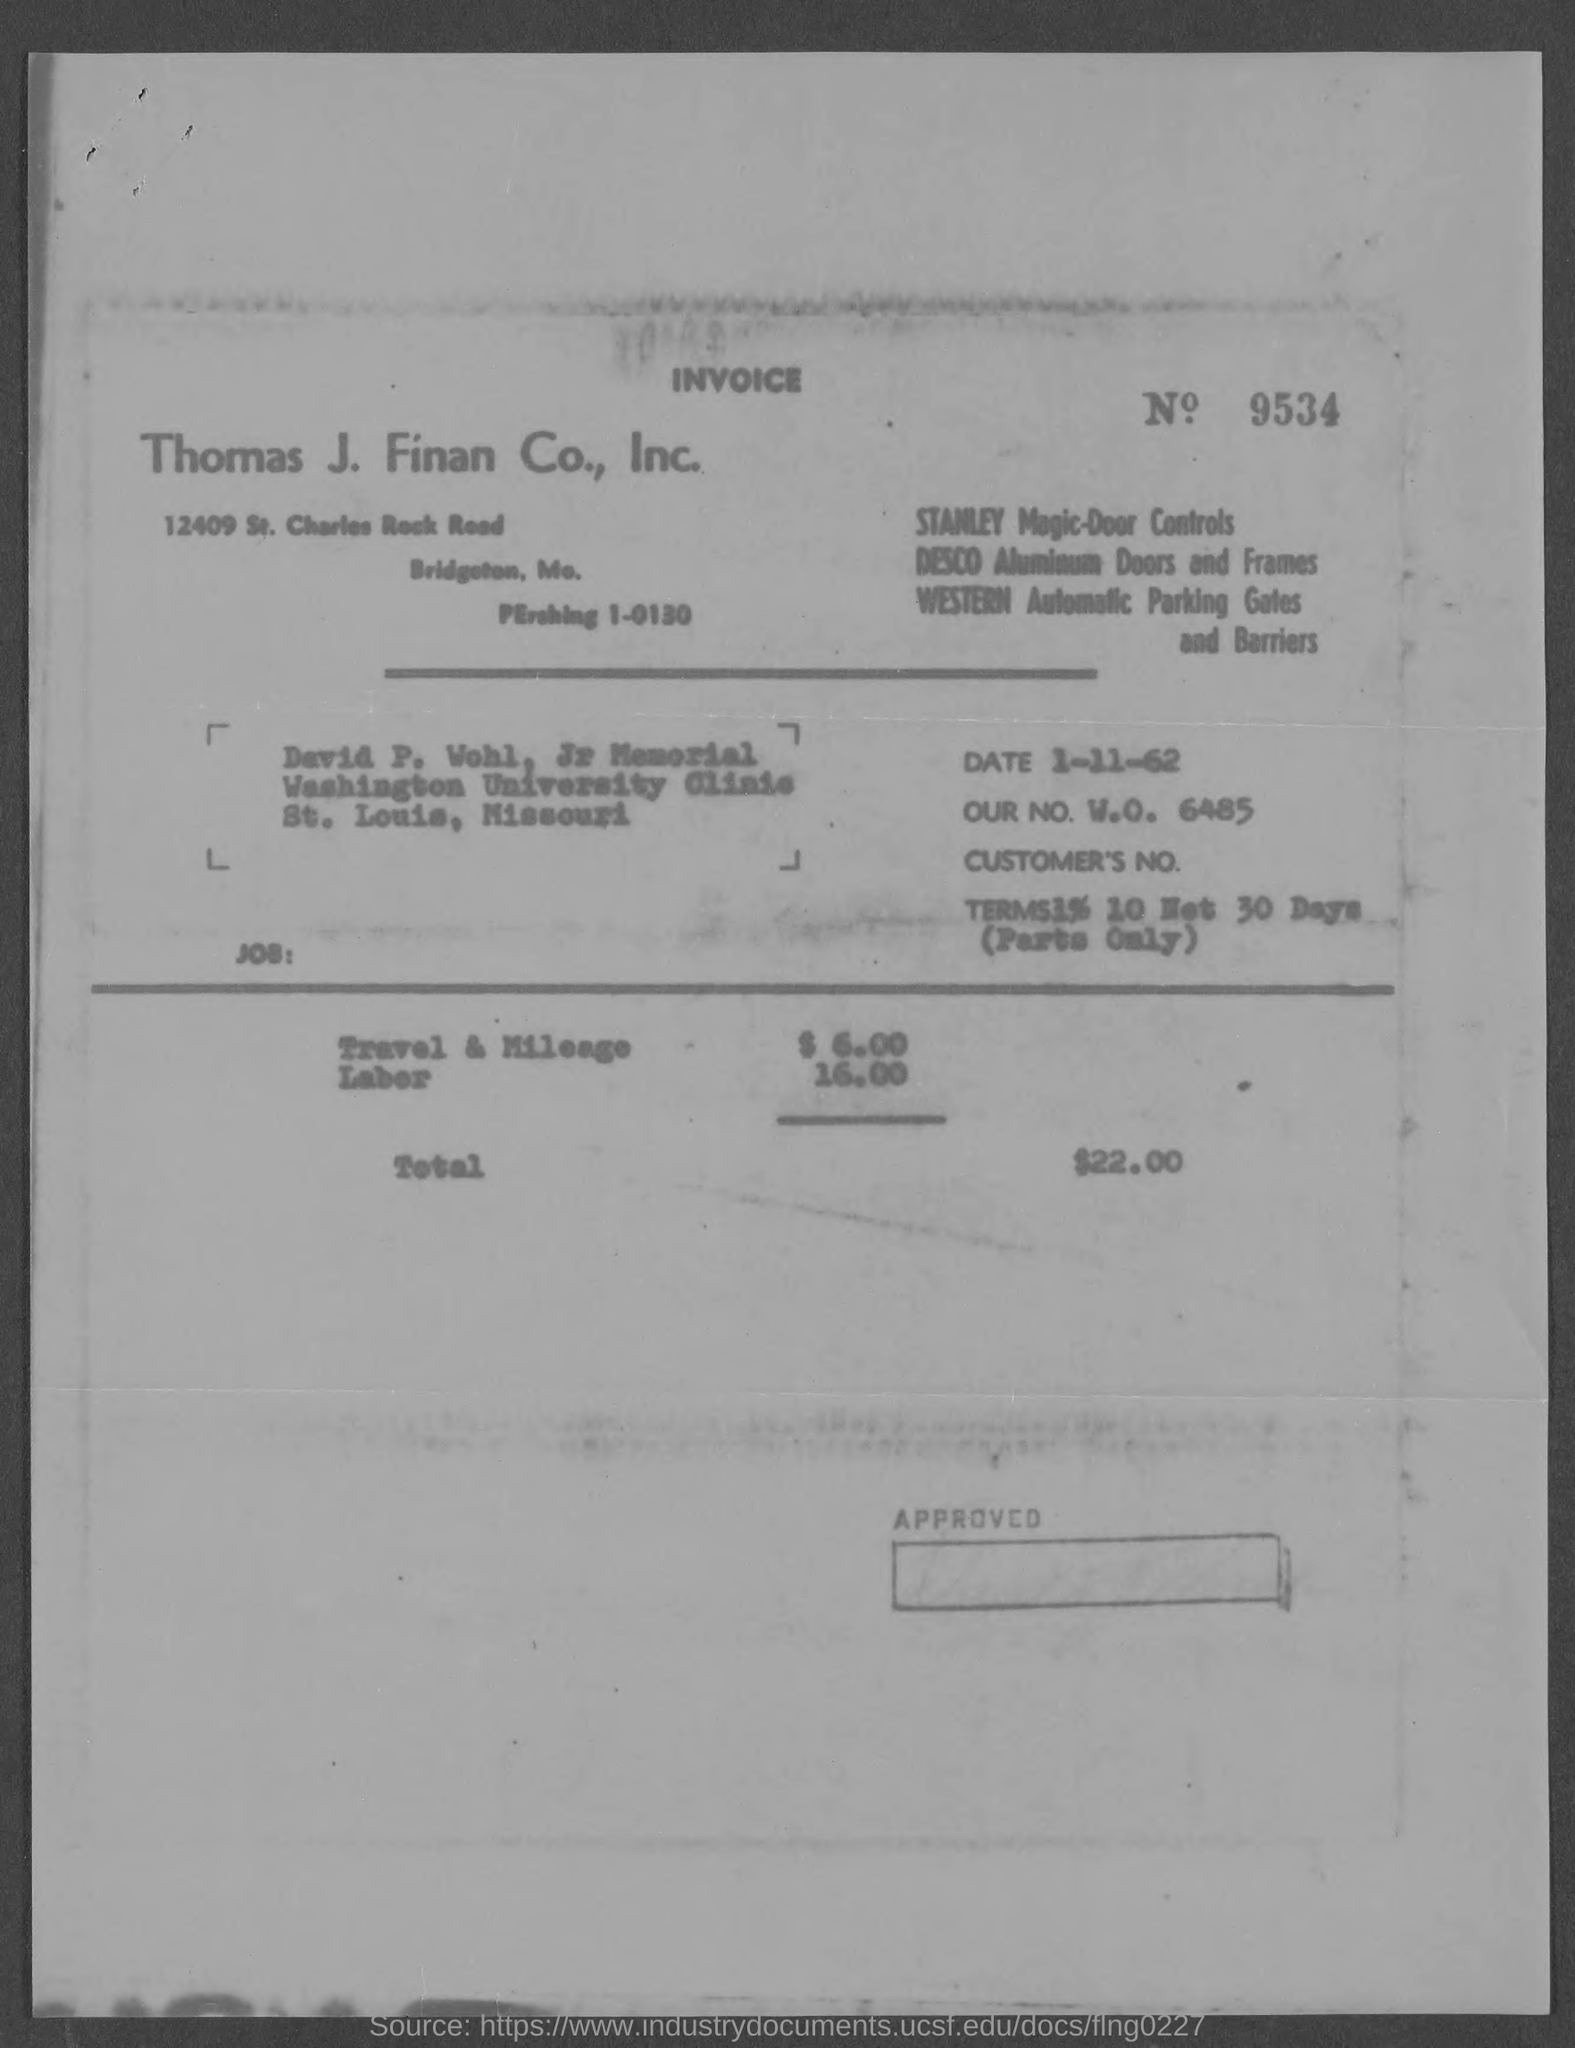What is the Invoice No. given in the document?
Provide a succinct answer. 9534. Which company is raising the invoice?
Provide a succinct answer. Thomas J. Finan Co., Inc. What is the date mentioned in the invoice?
Your answer should be very brief. 1-11-62. What is the invoice amount for travel & Mileage?
Keep it short and to the point. 6.00. What is the total amount of invoice as per the document?
Provide a short and direct response. $22.00. 